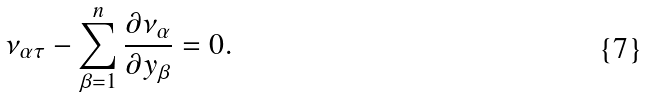Convert formula to latex. <formula><loc_0><loc_0><loc_500><loc_500>\nu _ { \alpha \tau } - \sum _ { \beta = 1 } ^ { n } \frac { \partial { \nu } _ { \alpha } } { \partial { y } _ { \beta } } = 0 .</formula> 